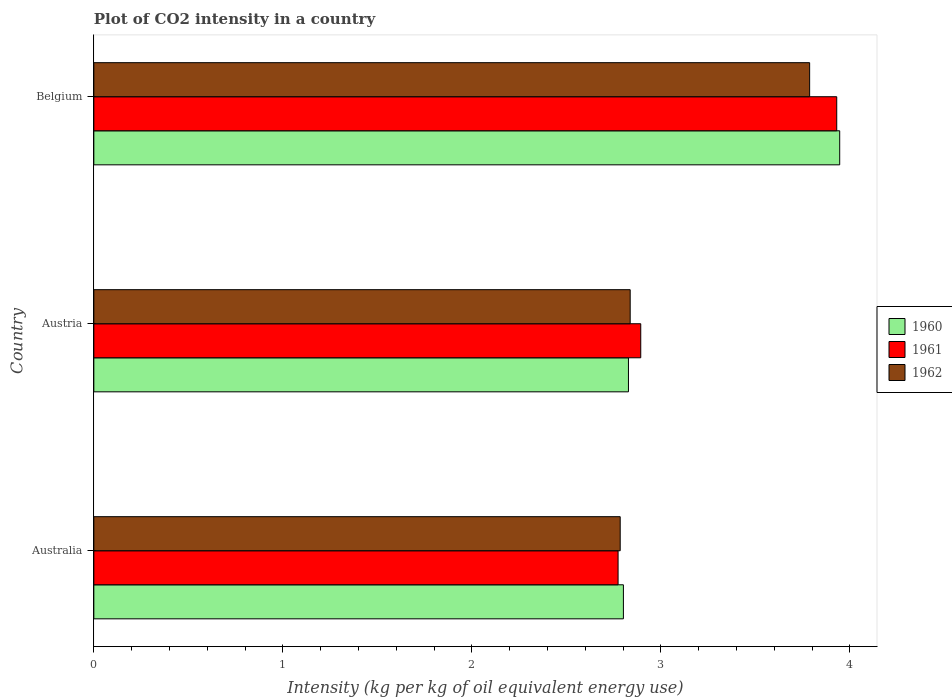How many different coloured bars are there?
Your answer should be compact. 3. How many groups of bars are there?
Offer a terse response. 3. How many bars are there on the 1st tick from the bottom?
Make the answer very short. 3. What is the label of the 1st group of bars from the top?
Your response must be concise. Belgium. What is the CO2 intensity in in 1960 in Belgium?
Your answer should be very brief. 3.95. Across all countries, what is the maximum CO2 intensity in in 1960?
Ensure brevity in your answer.  3.95. Across all countries, what is the minimum CO2 intensity in in 1960?
Offer a very short reply. 2.8. In which country was the CO2 intensity in in 1962 maximum?
Provide a succinct answer. Belgium. What is the total CO2 intensity in in 1962 in the graph?
Keep it short and to the point. 9.41. What is the difference between the CO2 intensity in in 1960 in Australia and that in Austria?
Offer a terse response. -0.03. What is the difference between the CO2 intensity in in 1962 in Austria and the CO2 intensity in in 1961 in Australia?
Give a very brief answer. 0.06. What is the average CO2 intensity in in 1961 per country?
Your answer should be very brief. 3.2. What is the difference between the CO2 intensity in in 1960 and CO2 intensity in in 1962 in Belgium?
Keep it short and to the point. 0.16. What is the ratio of the CO2 intensity in in 1960 in Australia to that in Austria?
Your response must be concise. 0.99. What is the difference between the highest and the second highest CO2 intensity in in 1962?
Your response must be concise. 0.95. What is the difference between the highest and the lowest CO2 intensity in in 1962?
Offer a very short reply. 1. In how many countries, is the CO2 intensity in in 1961 greater than the average CO2 intensity in in 1961 taken over all countries?
Ensure brevity in your answer.  1. What does the 2nd bar from the bottom in Australia represents?
Make the answer very short. 1961. How many bars are there?
Ensure brevity in your answer.  9. Are all the bars in the graph horizontal?
Ensure brevity in your answer.  Yes. How many countries are there in the graph?
Your answer should be very brief. 3. Are the values on the major ticks of X-axis written in scientific E-notation?
Your response must be concise. No. Does the graph contain grids?
Offer a terse response. No. Where does the legend appear in the graph?
Make the answer very short. Center right. What is the title of the graph?
Offer a terse response. Plot of CO2 intensity in a country. Does "1960" appear as one of the legend labels in the graph?
Make the answer very short. Yes. What is the label or title of the X-axis?
Provide a succinct answer. Intensity (kg per kg of oil equivalent energy use). What is the Intensity (kg per kg of oil equivalent energy use) of 1960 in Australia?
Ensure brevity in your answer.  2.8. What is the Intensity (kg per kg of oil equivalent energy use) in 1961 in Australia?
Your response must be concise. 2.77. What is the Intensity (kg per kg of oil equivalent energy use) of 1962 in Australia?
Give a very brief answer. 2.78. What is the Intensity (kg per kg of oil equivalent energy use) of 1960 in Austria?
Make the answer very short. 2.83. What is the Intensity (kg per kg of oil equivalent energy use) of 1961 in Austria?
Give a very brief answer. 2.89. What is the Intensity (kg per kg of oil equivalent energy use) of 1962 in Austria?
Offer a terse response. 2.84. What is the Intensity (kg per kg of oil equivalent energy use) in 1960 in Belgium?
Your answer should be very brief. 3.95. What is the Intensity (kg per kg of oil equivalent energy use) of 1961 in Belgium?
Ensure brevity in your answer.  3.93. What is the Intensity (kg per kg of oil equivalent energy use) of 1962 in Belgium?
Your response must be concise. 3.79. Across all countries, what is the maximum Intensity (kg per kg of oil equivalent energy use) in 1960?
Keep it short and to the point. 3.95. Across all countries, what is the maximum Intensity (kg per kg of oil equivalent energy use) of 1961?
Provide a short and direct response. 3.93. Across all countries, what is the maximum Intensity (kg per kg of oil equivalent energy use) of 1962?
Your answer should be very brief. 3.79. Across all countries, what is the minimum Intensity (kg per kg of oil equivalent energy use) of 1960?
Your answer should be compact. 2.8. Across all countries, what is the minimum Intensity (kg per kg of oil equivalent energy use) in 1961?
Your response must be concise. 2.77. Across all countries, what is the minimum Intensity (kg per kg of oil equivalent energy use) of 1962?
Your answer should be compact. 2.78. What is the total Intensity (kg per kg of oil equivalent energy use) of 1960 in the graph?
Keep it short and to the point. 9.58. What is the total Intensity (kg per kg of oil equivalent energy use) in 1961 in the graph?
Provide a succinct answer. 9.6. What is the total Intensity (kg per kg of oil equivalent energy use) in 1962 in the graph?
Give a very brief answer. 9.41. What is the difference between the Intensity (kg per kg of oil equivalent energy use) in 1960 in Australia and that in Austria?
Provide a short and direct response. -0.03. What is the difference between the Intensity (kg per kg of oil equivalent energy use) of 1961 in Australia and that in Austria?
Your answer should be very brief. -0.12. What is the difference between the Intensity (kg per kg of oil equivalent energy use) in 1962 in Australia and that in Austria?
Provide a succinct answer. -0.05. What is the difference between the Intensity (kg per kg of oil equivalent energy use) of 1960 in Australia and that in Belgium?
Make the answer very short. -1.14. What is the difference between the Intensity (kg per kg of oil equivalent energy use) in 1961 in Australia and that in Belgium?
Ensure brevity in your answer.  -1.16. What is the difference between the Intensity (kg per kg of oil equivalent energy use) in 1962 in Australia and that in Belgium?
Keep it short and to the point. -1. What is the difference between the Intensity (kg per kg of oil equivalent energy use) of 1960 in Austria and that in Belgium?
Provide a short and direct response. -1.12. What is the difference between the Intensity (kg per kg of oil equivalent energy use) of 1961 in Austria and that in Belgium?
Your response must be concise. -1.04. What is the difference between the Intensity (kg per kg of oil equivalent energy use) of 1962 in Austria and that in Belgium?
Provide a succinct answer. -0.95. What is the difference between the Intensity (kg per kg of oil equivalent energy use) in 1960 in Australia and the Intensity (kg per kg of oil equivalent energy use) in 1961 in Austria?
Ensure brevity in your answer.  -0.09. What is the difference between the Intensity (kg per kg of oil equivalent energy use) of 1960 in Australia and the Intensity (kg per kg of oil equivalent energy use) of 1962 in Austria?
Offer a terse response. -0.04. What is the difference between the Intensity (kg per kg of oil equivalent energy use) in 1961 in Australia and the Intensity (kg per kg of oil equivalent energy use) in 1962 in Austria?
Provide a succinct answer. -0.06. What is the difference between the Intensity (kg per kg of oil equivalent energy use) in 1960 in Australia and the Intensity (kg per kg of oil equivalent energy use) in 1961 in Belgium?
Your response must be concise. -1.13. What is the difference between the Intensity (kg per kg of oil equivalent energy use) in 1960 in Australia and the Intensity (kg per kg of oil equivalent energy use) in 1962 in Belgium?
Give a very brief answer. -0.99. What is the difference between the Intensity (kg per kg of oil equivalent energy use) in 1961 in Australia and the Intensity (kg per kg of oil equivalent energy use) in 1962 in Belgium?
Offer a terse response. -1.01. What is the difference between the Intensity (kg per kg of oil equivalent energy use) in 1960 in Austria and the Intensity (kg per kg of oil equivalent energy use) in 1961 in Belgium?
Ensure brevity in your answer.  -1.1. What is the difference between the Intensity (kg per kg of oil equivalent energy use) of 1960 in Austria and the Intensity (kg per kg of oil equivalent energy use) of 1962 in Belgium?
Offer a terse response. -0.96. What is the difference between the Intensity (kg per kg of oil equivalent energy use) of 1961 in Austria and the Intensity (kg per kg of oil equivalent energy use) of 1962 in Belgium?
Provide a short and direct response. -0.89. What is the average Intensity (kg per kg of oil equivalent energy use) in 1960 per country?
Your answer should be very brief. 3.19. What is the average Intensity (kg per kg of oil equivalent energy use) of 1961 per country?
Your answer should be very brief. 3.2. What is the average Intensity (kg per kg of oil equivalent energy use) of 1962 per country?
Your answer should be very brief. 3.14. What is the difference between the Intensity (kg per kg of oil equivalent energy use) of 1960 and Intensity (kg per kg of oil equivalent energy use) of 1961 in Australia?
Make the answer very short. 0.03. What is the difference between the Intensity (kg per kg of oil equivalent energy use) of 1960 and Intensity (kg per kg of oil equivalent energy use) of 1962 in Australia?
Your response must be concise. 0.02. What is the difference between the Intensity (kg per kg of oil equivalent energy use) of 1961 and Intensity (kg per kg of oil equivalent energy use) of 1962 in Australia?
Offer a very short reply. -0.01. What is the difference between the Intensity (kg per kg of oil equivalent energy use) of 1960 and Intensity (kg per kg of oil equivalent energy use) of 1961 in Austria?
Your answer should be compact. -0.07. What is the difference between the Intensity (kg per kg of oil equivalent energy use) of 1960 and Intensity (kg per kg of oil equivalent energy use) of 1962 in Austria?
Provide a succinct answer. -0.01. What is the difference between the Intensity (kg per kg of oil equivalent energy use) of 1961 and Intensity (kg per kg of oil equivalent energy use) of 1962 in Austria?
Make the answer very short. 0.06. What is the difference between the Intensity (kg per kg of oil equivalent energy use) in 1960 and Intensity (kg per kg of oil equivalent energy use) in 1961 in Belgium?
Ensure brevity in your answer.  0.02. What is the difference between the Intensity (kg per kg of oil equivalent energy use) in 1960 and Intensity (kg per kg of oil equivalent energy use) in 1962 in Belgium?
Your answer should be compact. 0.16. What is the difference between the Intensity (kg per kg of oil equivalent energy use) in 1961 and Intensity (kg per kg of oil equivalent energy use) in 1962 in Belgium?
Provide a short and direct response. 0.14. What is the ratio of the Intensity (kg per kg of oil equivalent energy use) in 1960 in Australia to that in Austria?
Offer a terse response. 0.99. What is the ratio of the Intensity (kg per kg of oil equivalent energy use) in 1961 in Australia to that in Austria?
Your response must be concise. 0.96. What is the ratio of the Intensity (kg per kg of oil equivalent energy use) of 1962 in Australia to that in Austria?
Your answer should be very brief. 0.98. What is the ratio of the Intensity (kg per kg of oil equivalent energy use) of 1960 in Australia to that in Belgium?
Your answer should be compact. 0.71. What is the ratio of the Intensity (kg per kg of oil equivalent energy use) of 1961 in Australia to that in Belgium?
Keep it short and to the point. 0.71. What is the ratio of the Intensity (kg per kg of oil equivalent energy use) in 1962 in Australia to that in Belgium?
Your answer should be very brief. 0.74. What is the ratio of the Intensity (kg per kg of oil equivalent energy use) in 1960 in Austria to that in Belgium?
Provide a short and direct response. 0.72. What is the ratio of the Intensity (kg per kg of oil equivalent energy use) in 1961 in Austria to that in Belgium?
Your answer should be compact. 0.74. What is the ratio of the Intensity (kg per kg of oil equivalent energy use) in 1962 in Austria to that in Belgium?
Make the answer very short. 0.75. What is the difference between the highest and the second highest Intensity (kg per kg of oil equivalent energy use) in 1960?
Your response must be concise. 1.12. What is the difference between the highest and the second highest Intensity (kg per kg of oil equivalent energy use) of 1961?
Give a very brief answer. 1.04. What is the difference between the highest and the second highest Intensity (kg per kg of oil equivalent energy use) in 1962?
Offer a very short reply. 0.95. What is the difference between the highest and the lowest Intensity (kg per kg of oil equivalent energy use) of 1960?
Ensure brevity in your answer.  1.14. What is the difference between the highest and the lowest Intensity (kg per kg of oil equivalent energy use) of 1961?
Your response must be concise. 1.16. 